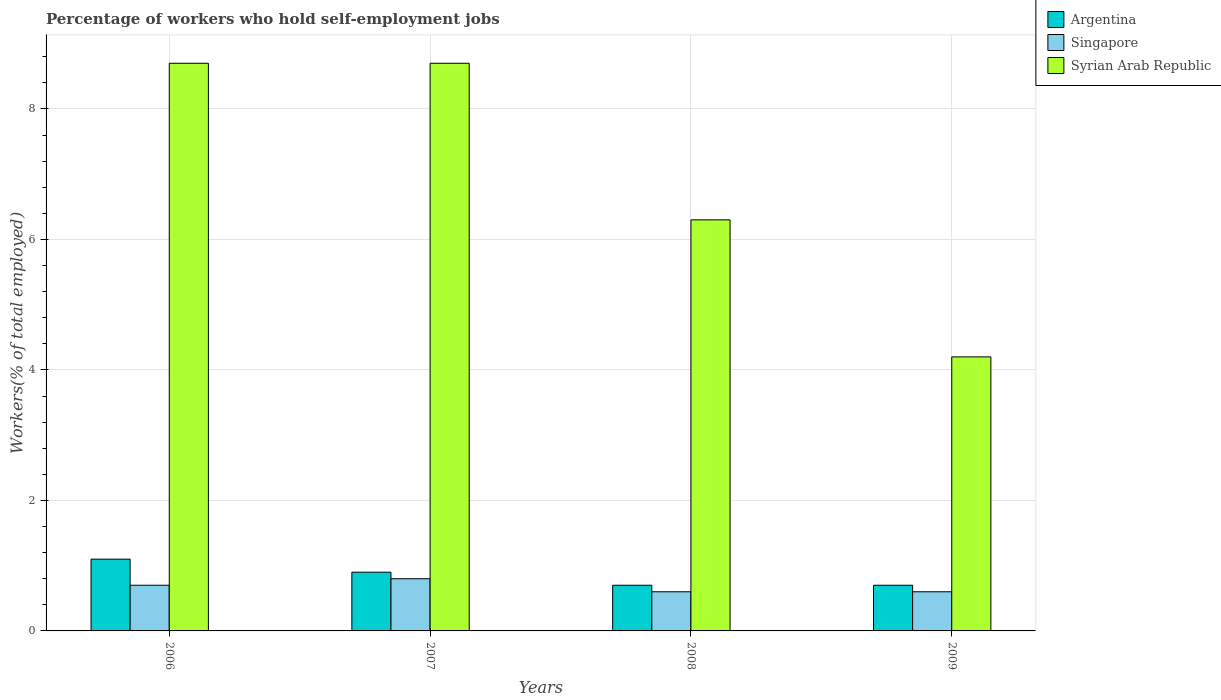How many different coloured bars are there?
Your answer should be compact. 3. How many groups of bars are there?
Offer a very short reply. 4. Are the number of bars per tick equal to the number of legend labels?
Keep it short and to the point. Yes. Are the number of bars on each tick of the X-axis equal?
Make the answer very short. Yes. How many bars are there on the 2nd tick from the left?
Your answer should be very brief. 3. What is the label of the 3rd group of bars from the left?
Your answer should be very brief. 2008. What is the percentage of self-employed workers in Singapore in 2008?
Make the answer very short. 0.6. Across all years, what is the maximum percentage of self-employed workers in Syrian Arab Republic?
Give a very brief answer. 8.7. Across all years, what is the minimum percentage of self-employed workers in Argentina?
Your answer should be compact. 0.7. In which year was the percentage of self-employed workers in Syrian Arab Republic maximum?
Keep it short and to the point. 2006. What is the total percentage of self-employed workers in Syrian Arab Republic in the graph?
Your response must be concise. 27.9. What is the difference between the percentage of self-employed workers in Syrian Arab Republic in 2007 and that in 2008?
Your answer should be compact. 2.4. What is the difference between the percentage of self-employed workers in Singapore in 2008 and the percentage of self-employed workers in Argentina in 2006?
Provide a succinct answer. -0.5. What is the average percentage of self-employed workers in Argentina per year?
Ensure brevity in your answer.  0.85. In the year 2006, what is the difference between the percentage of self-employed workers in Singapore and percentage of self-employed workers in Syrian Arab Republic?
Provide a succinct answer. -8. What is the ratio of the percentage of self-employed workers in Syrian Arab Republic in 2006 to that in 2008?
Keep it short and to the point. 1.38. Is the percentage of self-employed workers in Argentina in 2006 less than that in 2007?
Your answer should be compact. No. Is the difference between the percentage of self-employed workers in Singapore in 2006 and 2007 greater than the difference between the percentage of self-employed workers in Syrian Arab Republic in 2006 and 2007?
Keep it short and to the point. No. What is the difference between the highest and the second highest percentage of self-employed workers in Argentina?
Keep it short and to the point. 0.2. What is the difference between the highest and the lowest percentage of self-employed workers in Singapore?
Provide a short and direct response. 0.2. What does the 2nd bar from the left in 2009 represents?
Ensure brevity in your answer.  Singapore. What does the 2nd bar from the right in 2009 represents?
Offer a very short reply. Singapore. How many bars are there?
Your response must be concise. 12. Are all the bars in the graph horizontal?
Offer a terse response. No. How many years are there in the graph?
Make the answer very short. 4. What is the difference between two consecutive major ticks on the Y-axis?
Your answer should be very brief. 2. Does the graph contain any zero values?
Ensure brevity in your answer.  No. Where does the legend appear in the graph?
Offer a terse response. Top right. What is the title of the graph?
Ensure brevity in your answer.  Percentage of workers who hold self-employment jobs. Does "Isle of Man" appear as one of the legend labels in the graph?
Provide a succinct answer. No. What is the label or title of the Y-axis?
Your response must be concise. Workers(% of total employed). What is the Workers(% of total employed) in Argentina in 2006?
Your response must be concise. 1.1. What is the Workers(% of total employed) in Singapore in 2006?
Your answer should be very brief. 0.7. What is the Workers(% of total employed) in Syrian Arab Republic in 2006?
Ensure brevity in your answer.  8.7. What is the Workers(% of total employed) of Argentina in 2007?
Offer a very short reply. 0.9. What is the Workers(% of total employed) in Singapore in 2007?
Offer a terse response. 0.8. What is the Workers(% of total employed) in Syrian Arab Republic in 2007?
Provide a short and direct response. 8.7. What is the Workers(% of total employed) of Argentina in 2008?
Your response must be concise. 0.7. What is the Workers(% of total employed) of Singapore in 2008?
Give a very brief answer. 0.6. What is the Workers(% of total employed) in Syrian Arab Republic in 2008?
Ensure brevity in your answer.  6.3. What is the Workers(% of total employed) of Argentina in 2009?
Offer a terse response. 0.7. What is the Workers(% of total employed) in Singapore in 2009?
Give a very brief answer. 0.6. What is the Workers(% of total employed) in Syrian Arab Republic in 2009?
Your answer should be very brief. 4.2. Across all years, what is the maximum Workers(% of total employed) in Argentina?
Your answer should be compact. 1.1. Across all years, what is the maximum Workers(% of total employed) in Singapore?
Ensure brevity in your answer.  0.8. Across all years, what is the maximum Workers(% of total employed) of Syrian Arab Republic?
Your response must be concise. 8.7. Across all years, what is the minimum Workers(% of total employed) in Argentina?
Your answer should be compact. 0.7. Across all years, what is the minimum Workers(% of total employed) of Singapore?
Your answer should be very brief. 0.6. Across all years, what is the minimum Workers(% of total employed) in Syrian Arab Republic?
Offer a terse response. 4.2. What is the total Workers(% of total employed) in Singapore in the graph?
Ensure brevity in your answer.  2.7. What is the total Workers(% of total employed) in Syrian Arab Republic in the graph?
Ensure brevity in your answer.  27.9. What is the difference between the Workers(% of total employed) in Argentina in 2006 and that in 2008?
Your answer should be very brief. 0.4. What is the difference between the Workers(% of total employed) in Singapore in 2006 and that in 2008?
Make the answer very short. 0.1. What is the difference between the Workers(% of total employed) of Argentina in 2006 and that in 2009?
Provide a succinct answer. 0.4. What is the difference between the Workers(% of total employed) of Singapore in 2006 and that in 2009?
Make the answer very short. 0.1. What is the difference between the Workers(% of total employed) in Singapore in 2007 and that in 2008?
Offer a terse response. 0.2. What is the difference between the Workers(% of total employed) of Argentina in 2007 and that in 2009?
Your answer should be compact. 0.2. What is the difference between the Workers(% of total employed) of Syrian Arab Republic in 2007 and that in 2009?
Keep it short and to the point. 4.5. What is the difference between the Workers(% of total employed) in Argentina in 2008 and that in 2009?
Your answer should be compact. 0. What is the difference between the Workers(% of total employed) in Singapore in 2008 and that in 2009?
Ensure brevity in your answer.  0. What is the difference between the Workers(% of total employed) of Argentina in 2006 and the Workers(% of total employed) of Singapore in 2007?
Offer a terse response. 0.3. What is the difference between the Workers(% of total employed) in Singapore in 2006 and the Workers(% of total employed) in Syrian Arab Republic in 2007?
Your answer should be very brief. -8. What is the difference between the Workers(% of total employed) in Argentina in 2006 and the Workers(% of total employed) in Syrian Arab Republic in 2008?
Provide a short and direct response. -5.2. What is the difference between the Workers(% of total employed) of Singapore in 2006 and the Workers(% of total employed) of Syrian Arab Republic in 2008?
Provide a short and direct response. -5.6. What is the difference between the Workers(% of total employed) of Argentina in 2006 and the Workers(% of total employed) of Singapore in 2009?
Your answer should be compact. 0.5. What is the difference between the Workers(% of total employed) of Argentina in 2007 and the Workers(% of total employed) of Syrian Arab Republic in 2008?
Ensure brevity in your answer.  -5.4. What is the difference between the Workers(% of total employed) in Singapore in 2007 and the Workers(% of total employed) in Syrian Arab Republic in 2008?
Your answer should be very brief. -5.5. What is the difference between the Workers(% of total employed) of Argentina in 2007 and the Workers(% of total employed) of Syrian Arab Republic in 2009?
Provide a short and direct response. -3.3. What is the difference between the Workers(% of total employed) in Singapore in 2007 and the Workers(% of total employed) in Syrian Arab Republic in 2009?
Your answer should be compact. -3.4. What is the difference between the Workers(% of total employed) in Argentina in 2008 and the Workers(% of total employed) in Singapore in 2009?
Make the answer very short. 0.1. What is the average Workers(% of total employed) in Argentina per year?
Keep it short and to the point. 0.85. What is the average Workers(% of total employed) in Singapore per year?
Your answer should be compact. 0.68. What is the average Workers(% of total employed) of Syrian Arab Republic per year?
Offer a very short reply. 6.97. In the year 2006, what is the difference between the Workers(% of total employed) in Argentina and Workers(% of total employed) in Singapore?
Provide a succinct answer. 0.4. In the year 2008, what is the difference between the Workers(% of total employed) of Argentina and Workers(% of total employed) of Singapore?
Keep it short and to the point. 0.1. In the year 2009, what is the difference between the Workers(% of total employed) of Argentina and Workers(% of total employed) of Syrian Arab Republic?
Your response must be concise. -3.5. In the year 2009, what is the difference between the Workers(% of total employed) in Singapore and Workers(% of total employed) in Syrian Arab Republic?
Provide a short and direct response. -3.6. What is the ratio of the Workers(% of total employed) of Argentina in 2006 to that in 2007?
Your answer should be very brief. 1.22. What is the ratio of the Workers(% of total employed) in Singapore in 2006 to that in 2007?
Keep it short and to the point. 0.88. What is the ratio of the Workers(% of total employed) in Syrian Arab Republic in 2006 to that in 2007?
Your answer should be compact. 1. What is the ratio of the Workers(% of total employed) of Argentina in 2006 to that in 2008?
Ensure brevity in your answer.  1.57. What is the ratio of the Workers(% of total employed) in Singapore in 2006 to that in 2008?
Offer a very short reply. 1.17. What is the ratio of the Workers(% of total employed) of Syrian Arab Republic in 2006 to that in 2008?
Offer a terse response. 1.38. What is the ratio of the Workers(% of total employed) of Argentina in 2006 to that in 2009?
Offer a terse response. 1.57. What is the ratio of the Workers(% of total employed) of Syrian Arab Republic in 2006 to that in 2009?
Your answer should be very brief. 2.07. What is the ratio of the Workers(% of total employed) of Argentina in 2007 to that in 2008?
Your answer should be compact. 1.29. What is the ratio of the Workers(% of total employed) in Singapore in 2007 to that in 2008?
Provide a succinct answer. 1.33. What is the ratio of the Workers(% of total employed) in Syrian Arab Republic in 2007 to that in 2008?
Offer a very short reply. 1.38. What is the ratio of the Workers(% of total employed) of Argentina in 2007 to that in 2009?
Provide a short and direct response. 1.29. What is the ratio of the Workers(% of total employed) of Syrian Arab Republic in 2007 to that in 2009?
Offer a terse response. 2.07. What is the ratio of the Workers(% of total employed) of Singapore in 2008 to that in 2009?
Give a very brief answer. 1. What is the ratio of the Workers(% of total employed) of Syrian Arab Republic in 2008 to that in 2009?
Give a very brief answer. 1.5. What is the difference between the highest and the second highest Workers(% of total employed) in Singapore?
Your response must be concise. 0.1. 